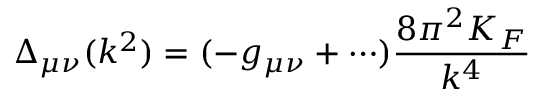<formula> <loc_0><loc_0><loc_500><loc_500>\Delta _ { \mu \nu } ( k ^ { 2 } ) = ( - g _ { \mu \nu } + \cdots ) \frac { 8 \pi ^ { 2 } K _ { F } } { k ^ { 4 } }</formula> 